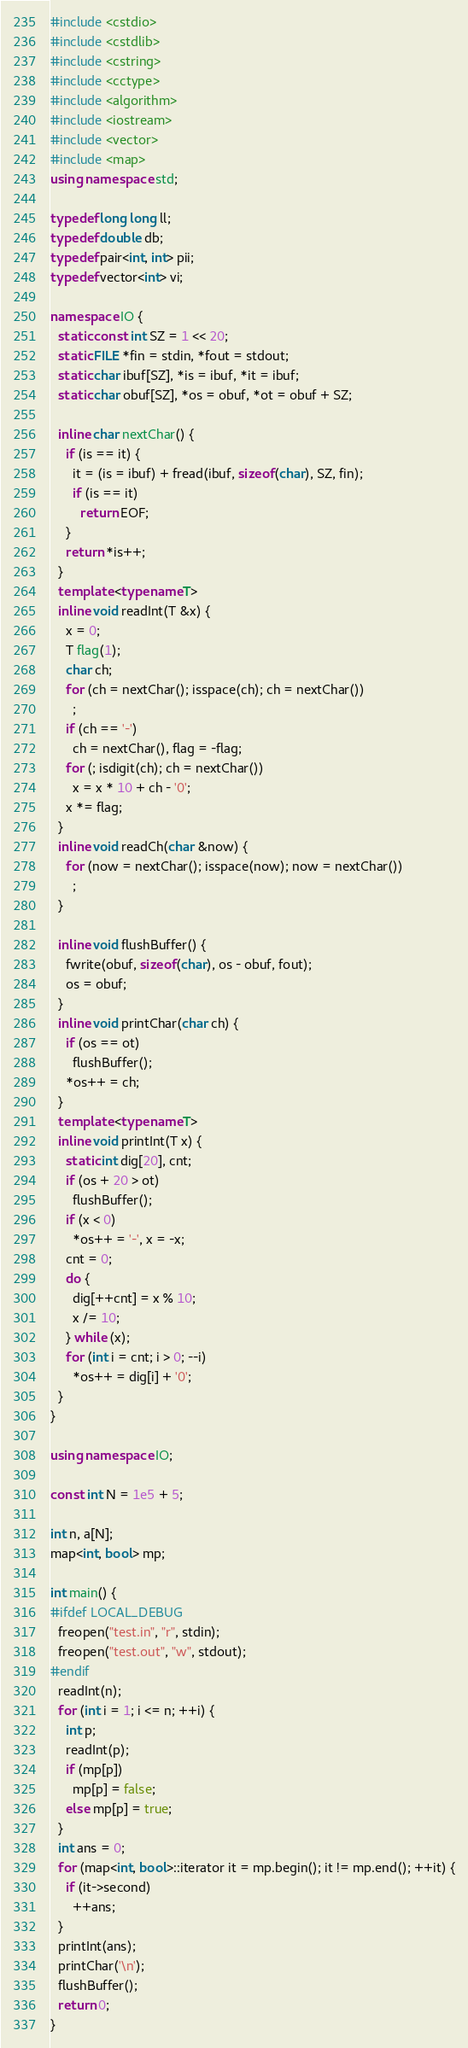Convert code to text. <code><loc_0><loc_0><loc_500><loc_500><_C++_>#include <cstdio>
#include <cstdlib>
#include <cstring>
#include <cctype>
#include <algorithm>
#include <iostream>
#include <vector>
#include <map>
using namespace std;

typedef long long ll;
typedef double db;
typedef pair<int, int> pii;
typedef vector<int> vi;

namespace IO {
  static const int SZ = 1 << 20;
  static FILE *fin = stdin, *fout = stdout;
  static char ibuf[SZ], *is = ibuf, *it = ibuf;
  static char obuf[SZ], *os = obuf, *ot = obuf + SZ;

  inline char nextChar() {
    if (is == it) {
      it = (is = ibuf) + fread(ibuf, sizeof(char), SZ, fin);
      if (is == it)
        return EOF;
    }
    return *is++;
  }
  template <typename T>
  inline void readInt(T &x) {
    x = 0;
    T flag(1);
    char ch;
    for (ch = nextChar(); isspace(ch); ch = nextChar())
      ;
    if (ch == '-')
      ch = nextChar(), flag = -flag;
    for (; isdigit(ch); ch = nextChar())
      x = x * 10 + ch - '0';
    x *= flag;
  }
  inline void readCh(char &now) {
    for (now = nextChar(); isspace(now); now = nextChar())
      ;
  }

  inline void flushBuffer() {
    fwrite(obuf, sizeof(char), os - obuf, fout);
    os = obuf;
  }
  inline void printChar(char ch) {
    if (os == ot)
      flushBuffer();
    *os++ = ch;
  }
  template <typename T>
  inline void printInt(T x) {
    static int dig[20], cnt;
    if (os + 20 > ot)
      flushBuffer();
    if (x < 0)
      *os++ = '-', x = -x;
    cnt = 0;
    do {
      dig[++cnt] = x % 10;
      x /= 10;
    } while (x);
    for (int i = cnt; i > 0; --i)
      *os++ = dig[i] + '0';
  }
}

using namespace IO;

const int N = 1e5 + 5;

int n, a[N];
map<int, bool> mp;

int main() {
#ifdef LOCAL_DEBUG
  freopen("test.in", "r", stdin);
  freopen("test.out", "w", stdout);
#endif
  readInt(n);
  for (int i = 1; i <= n; ++i) {
    int p;
    readInt(p);
    if (mp[p])
      mp[p] = false;
    else mp[p] = true;
  }
  int ans = 0;
  for (map<int, bool>::iterator it = mp.begin(); it != mp.end(); ++it) {
    if (it->second)
      ++ans;
  }
  printInt(ans);
  printChar('\n');
  flushBuffer();
  return 0;
}</code> 